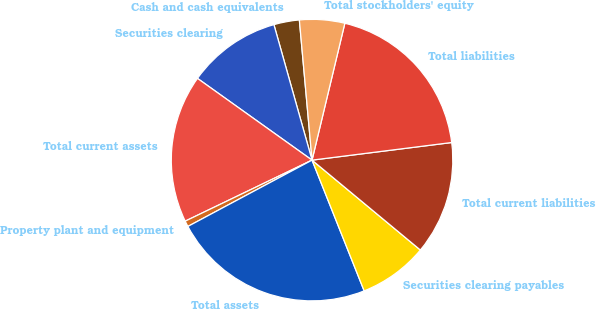Convert chart to OTSL. <chart><loc_0><loc_0><loc_500><loc_500><pie_chart><fcel>Cash and cash equivalents<fcel>Securities clearing<fcel>Total current assets<fcel>Property plant and equipment<fcel>Total assets<fcel>Securities clearing payables<fcel>Total current liabilities<fcel>Total liabilities<fcel>Total stockholders' equity<nl><fcel>2.93%<fcel>10.77%<fcel>17.0%<fcel>0.67%<fcel>23.23%<fcel>7.94%<fcel>13.02%<fcel>19.26%<fcel>5.18%<nl></chart> 